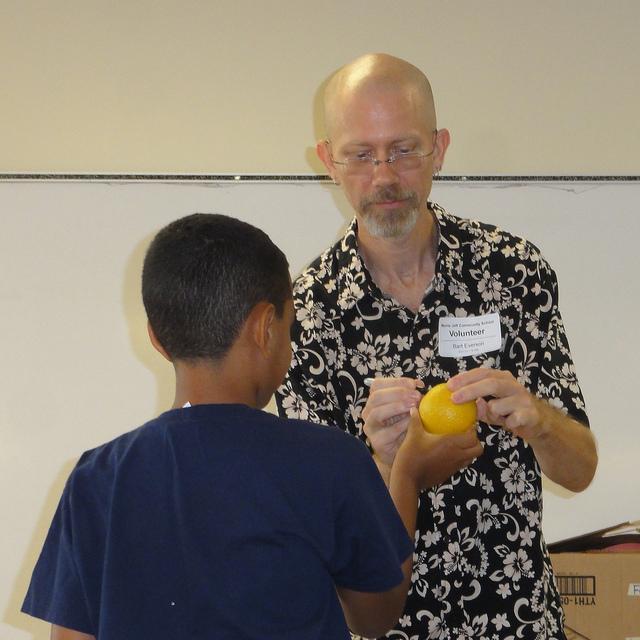What is behind the older man in the scene?
Write a very short answer. Whiteboard. What color is the object?
Short answer required. Yellow. Does this man have hair?
Keep it brief. No. Is this a party?
Write a very short answer. No. What are the people looking at?
Quick response, please. Orange. 